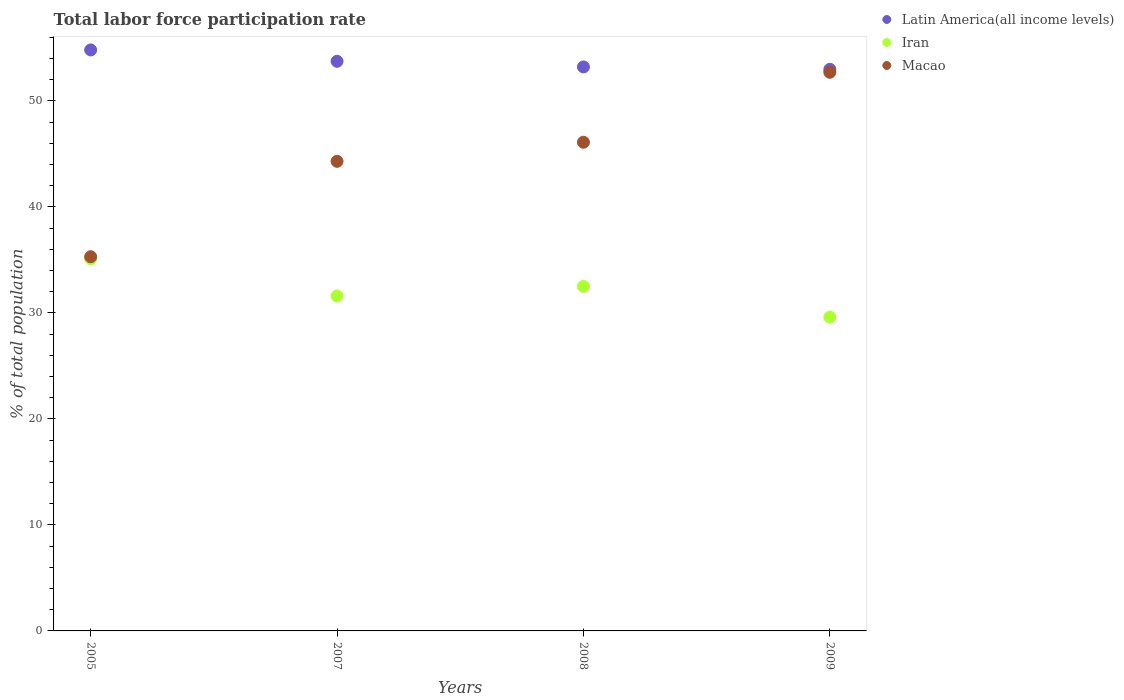What is the total labor force participation rate in Latin America(all income levels) in 2009?
Offer a terse response. 52.98. Across all years, what is the maximum total labor force participation rate in Latin America(all income levels)?
Provide a short and direct response. 54.81. Across all years, what is the minimum total labor force participation rate in Latin America(all income levels)?
Provide a short and direct response. 52.98. In which year was the total labor force participation rate in Iran minimum?
Your answer should be very brief. 2009. What is the total total labor force participation rate in Latin America(all income levels) in the graph?
Your answer should be very brief. 214.73. What is the difference between the total labor force participation rate in Iran in 2005 and that in 2007?
Your response must be concise. 3.5. What is the difference between the total labor force participation rate in Latin America(all income levels) in 2005 and the total labor force participation rate in Iran in 2007?
Provide a short and direct response. 23.21. What is the average total labor force participation rate in Macao per year?
Provide a succinct answer. 44.6. In the year 2008, what is the difference between the total labor force participation rate in Iran and total labor force participation rate in Macao?
Provide a short and direct response. -13.6. What is the ratio of the total labor force participation rate in Latin America(all income levels) in 2008 to that in 2009?
Provide a succinct answer. 1. What is the difference between the highest and the second highest total labor force participation rate in Latin America(all income levels)?
Your answer should be very brief. 1.07. What is the difference between the highest and the lowest total labor force participation rate in Iran?
Make the answer very short. 5.5. Is the sum of the total labor force participation rate in Macao in 2005 and 2009 greater than the maximum total labor force participation rate in Iran across all years?
Your answer should be compact. Yes. Is it the case that in every year, the sum of the total labor force participation rate in Latin America(all income levels) and total labor force participation rate in Iran  is greater than the total labor force participation rate in Macao?
Make the answer very short. Yes. Does the total labor force participation rate in Macao monotonically increase over the years?
Keep it short and to the point. Yes. Is the total labor force participation rate in Latin America(all income levels) strictly greater than the total labor force participation rate in Iran over the years?
Provide a short and direct response. Yes. How many dotlines are there?
Your answer should be compact. 3. How many years are there in the graph?
Ensure brevity in your answer.  4. Are the values on the major ticks of Y-axis written in scientific E-notation?
Your answer should be very brief. No. Does the graph contain any zero values?
Your response must be concise. No. Does the graph contain grids?
Keep it short and to the point. No. How are the legend labels stacked?
Ensure brevity in your answer.  Vertical. What is the title of the graph?
Your response must be concise. Total labor force participation rate. Does "St. Kitts and Nevis" appear as one of the legend labels in the graph?
Offer a terse response. No. What is the label or title of the X-axis?
Provide a short and direct response. Years. What is the label or title of the Y-axis?
Offer a terse response. % of total population. What is the % of total population of Latin America(all income levels) in 2005?
Provide a short and direct response. 54.81. What is the % of total population of Iran in 2005?
Give a very brief answer. 35.1. What is the % of total population in Macao in 2005?
Make the answer very short. 35.3. What is the % of total population of Latin America(all income levels) in 2007?
Make the answer very short. 53.74. What is the % of total population in Iran in 2007?
Keep it short and to the point. 31.6. What is the % of total population of Macao in 2007?
Your answer should be compact. 44.3. What is the % of total population in Latin America(all income levels) in 2008?
Your answer should be very brief. 53.2. What is the % of total population of Iran in 2008?
Your answer should be compact. 32.5. What is the % of total population of Macao in 2008?
Offer a terse response. 46.1. What is the % of total population in Latin America(all income levels) in 2009?
Your answer should be compact. 52.98. What is the % of total population in Iran in 2009?
Keep it short and to the point. 29.6. What is the % of total population of Macao in 2009?
Make the answer very short. 52.7. Across all years, what is the maximum % of total population of Latin America(all income levels)?
Provide a succinct answer. 54.81. Across all years, what is the maximum % of total population in Iran?
Your answer should be compact. 35.1. Across all years, what is the maximum % of total population of Macao?
Give a very brief answer. 52.7. Across all years, what is the minimum % of total population of Latin America(all income levels)?
Provide a succinct answer. 52.98. Across all years, what is the minimum % of total population in Iran?
Offer a terse response. 29.6. Across all years, what is the minimum % of total population in Macao?
Provide a succinct answer. 35.3. What is the total % of total population in Latin America(all income levels) in the graph?
Your answer should be compact. 214.73. What is the total % of total population in Iran in the graph?
Give a very brief answer. 128.8. What is the total % of total population of Macao in the graph?
Your response must be concise. 178.4. What is the difference between the % of total population of Latin America(all income levels) in 2005 and that in 2007?
Provide a short and direct response. 1.07. What is the difference between the % of total population of Macao in 2005 and that in 2007?
Your response must be concise. -9. What is the difference between the % of total population of Latin America(all income levels) in 2005 and that in 2008?
Your response must be concise. 1.6. What is the difference between the % of total population in Iran in 2005 and that in 2008?
Your answer should be compact. 2.6. What is the difference between the % of total population in Macao in 2005 and that in 2008?
Give a very brief answer. -10.8. What is the difference between the % of total population of Latin America(all income levels) in 2005 and that in 2009?
Provide a short and direct response. 1.83. What is the difference between the % of total population of Iran in 2005 and that in 2009?
Provide a succinct answer. 5.5. What is the difference between the % of total population in Macao in 2005 and that in 2009?
Your answer should be very brief. -17.4. What is the difference between the % of total population of Latin America(all income levels) in 2007 and that in 2008?
Offer a very short reply. 0.53. What is the difference between the % of total population in Latin America(all income levels) in 2007 and that in 2009?
Provide a short and direct response. 0.76. What is the difference between the % of total population in Iran in 2007 and that in 2009?
Ensure brevity in your answer.  2. What is the difference between the % of total population in Latin America(all income levels) in 2008 and that in 2009?
Ensure brevity in your answer.  0.23. What is the difference between the % of total population in Iran in 2008 and that in 2009?
Provide a succinct answer. 2.9. What is the difference between the % of total population in Macao in 2008 and that in 2009?
Your response must be concise. -6.6. What is the difference between the % of total population of Latin America(all income levels) in 2005 and the % of total population of Iran in 2007?
Make the answer very short. 23.21. What is the difference between the % of total population in Latin America(all income levels) in 2005 and the % of total population in Macao in 2007?
Make the answer very short. 10.51. What is the difference between the % of total population in Iran in 2005 and the % of total population in Macao in 2007?
Your answer should be very brief. -9.2. What is the difference between the % of total population of Latin America(all income levels) in 2005 and the % of total population of Iran in 2008?
Offer a terse response. 22.31. What is the difference between the % of total population of Latin America(all income levels) in 2005 and the % of total population of Macao in 2008?
Your response must be concise. 8.71. What is the difference between the % of total population of Latin America(all income levels) in 2005 and the % of total population of Iran in 2009?
Make the answer very short. 25.21. What is the difference between the % of total population in Latin America(all income levels) in 2005 and the % of total population in Macao in 2009?
Provide a succinct answer. 2.11. What is the difference between the % of total population in Iran in 2005 and the % of total population in Macao in 2009?
Offer a terse response. -17.6. What is the difference between the % of total population in Latin America(all income levels) in 2007 and the % of total population in Iran in 2008?
Make the answer very short. 21.24. What is the difference between the % of total population in Latin America(all income levels) in 2007 and the % of total population in Macao in 2008?
Provide a short and direct response. 7.64. What is the difference between the % of total population of Iran in 2007 and the % of total population of Macao in 2008?
Give a very brief answer. -14.5. What is the difference between the % of total population in Latin America(all income levels) in 2007 and the % of total population in Iran in 2009?
Ensure brevity in your answer.  24.14. What is the difference between the % of total population in Latin America(all income levels) in 2007 and the % of total population in Macao in 2009?
Provide a succinct answer. 1.04. What is the difference between the % of total population of Iran in 2007 and the % of total population of Macao in 2009?
Ensure brevity in your answer.  -21.1. What is the difference between the % of total population in Latin America(all income levels) in 2008 and the % of total population in Iran in 2009?
Ensure brevity in your answer.  23.6. What is the difference between the % of total population in Latin America(all income levels) in 2008 and the % of total population in Macao in 2009?
Give a very brief answer. 0.5. What is the difference between the % of total population of Iran in 2008 and the % of total population of Macao in 2009?
Your answer should be very brief. -20.2. What is the average % of total population in Latin America(all income levels) per year?
Offer a terse response. 53.68. What is the average % of total population in Iran per year?
Your answer should be compact. 32.2. What is the average % of total population in Macao per year?
Offer a terse response. 44.6. In the year 2005, what is the difference between the % of total population of Latin America(all income levels) and % of total population of Iran?
Your response must be concise. 19.71. In the year 2005, what is the difference between the % of total population of Latin America(all income levels) and % of total population of Macao?
Provide a succinct answer. 19.51. In the year 2007, what is the difference between the % of total population of Latin America(all income levels) and % of total population of Iran?
Provide a succinct answer. 22.14. In the year 2007, what is the difference between the % of total population of Latin America(all income levels) and % of total population of Macao?
Your answer should be compact. 9.44. In the year 2007, what is the difference between the % of total population in Iran and % of total population in Macao?
Provide a succinct answer. -12.7. In the year 2008, what is the difference between the % of total population of Latin America(all income levels) and % of total population of Iran?
Ensure brevity in your answer.  20.7. In the year 2008, what is the difference between the % of total population of Latin America(all income levels) and % of total population of Macao?
Make the answer very short. 7.1. In the year 2008, what is the difference between the % of total population of Iran and % of total population of Macao?
Give a very brief answer. -13.6. In the year 2009, what is the difference between the % of total population of Latin America(all income levels) and % of total population of Iran?
Offer a terse response. 23.38. In the year 2009, what is the difference between the % of total population in Latin America(all income levels) and % of total population in Macao?
Give a very brief answer. 0.28. In the year 2009, what is the difference between the % of total population of Iran and % of total population of Macao?
Offer a very short reply. -23.1. What is the ratio of the % of total population in Latin America(all income levels) in 2005 to that in 2007?
Give a very brief answer. 1.02. What is the ratio of the % of total population in Iran in 2005 to that in 2007?
Offer a terse response. 1.11. What is the ratio of the % of total population of Macao in 2005 to that in 2007?
Your answer should be very brief. 0.8. What is the ratio of the % of total population of Latin America(all income levels) in 2005 to that in 2008?
Your answer should be compact. 1.03. What is the ratio of the % of total population in Macao in 2005 to that in 2008?
Provide a succinct answer. 0.77. What is the ratio of the % of total population in Latin America(all income levels) in 2005 to that in 2009?
Offer a terse response. 1.03. What is the ratio of the % of total population of Iran in 2005 to that in 2009?
Offer a very short reply. 1.19. What is the ratio of the % of total population in Macao in 2005 to that in 2009?
Provide a succinct answer. 0.67. What is the ratio of the % of total population of Iran in 2007 to that in 2008?
Your response must be concise. 0.97. What is the ratio of the % of total population of Macao in 2007 to that in 2008?
Your answer should be very brief. 0.96. What is the ratio of the % of total population in Latin America(all income levels) in 2007 to that in 2009?
Provide a short and direct response. 1.01. What is the ratio of the % of total population in Iran in 2007 to that in 2009?
Offer a very short reply. 1.07. What is the ratio of the % of total population of Macao in 2007 to that in 2009?
Provide a succinct answer. 0.84. What is the ratio of the % of total population of Iran in 2008 to that in 2009?
Offer a terse response. 1.1. What is the ratio of the % of total population of Macao in 2008 to that in 2009?
Ensure brevity in your answer.  0.87. What is the difference between the highest and the second highest % of total population of Latin America(all income levels)?
Offer a terse response. 1.07. What is the difference between the highest and the second highest % of total population of Iran?
Your response must be concise. 2.6. What is the difference between the highest and the second highest % of total population in Macao?
Make the answer very short. 6.6. What is the difference between the highest and the lowest % of total population in Latin America(all income levels)?
Give a very brief answer. 1.83. 